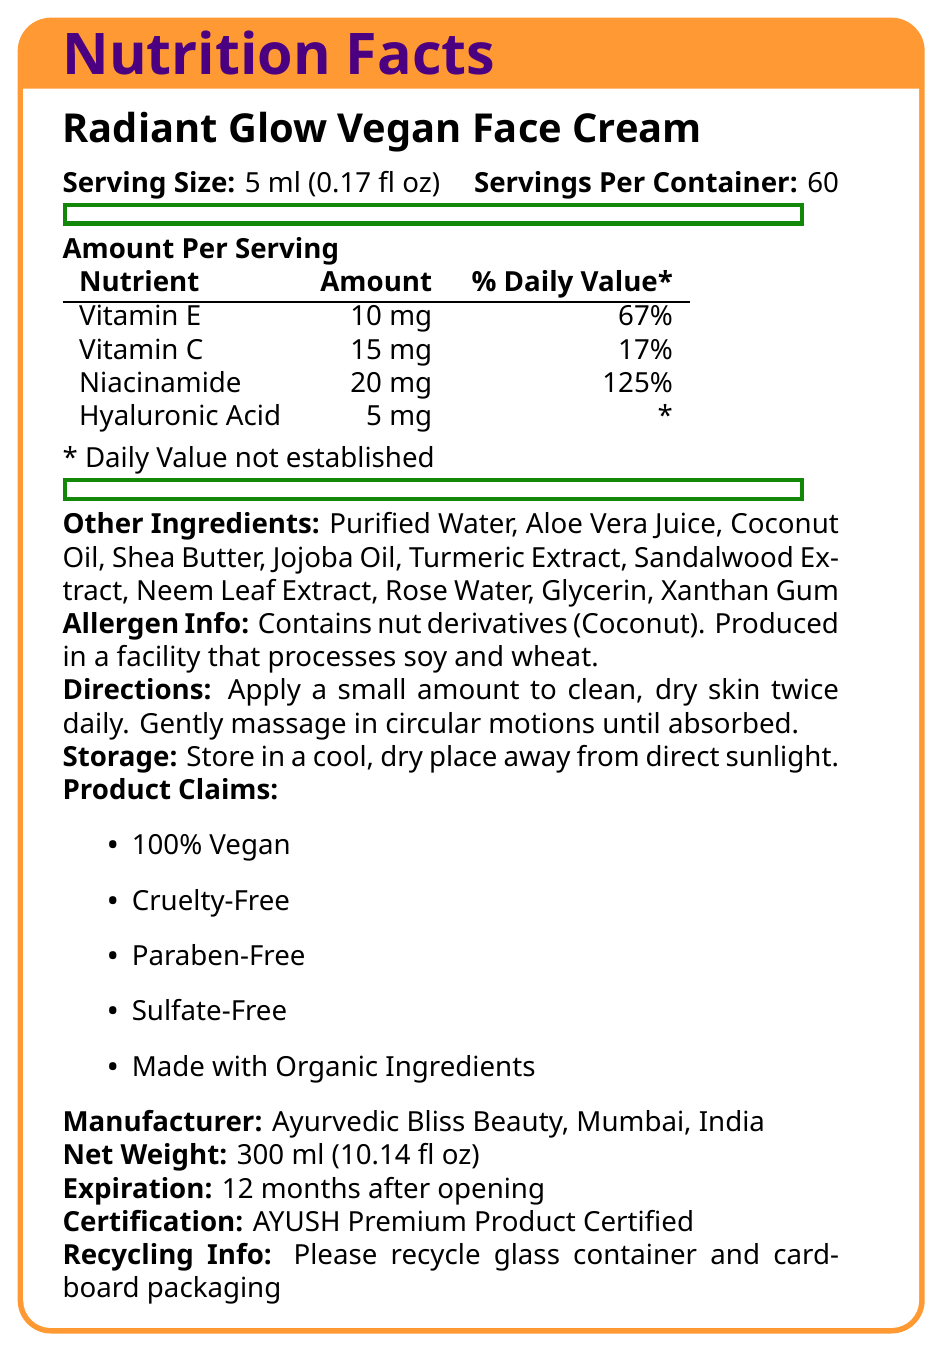what is the serving size of the product? The serving size is mentioned under the product name "Radiant Glow Vegan Face Cream".
Answer: 5 ml (0.17 fl oz) how many servings are there in the container? The number of servings per container is listed next to the serving size.
Answer: 60 which nutrient has the highest percentage daily value? Niacinamide has a daily value of 125%, which is higher than the daily values of the other listed nutrients.
Answer: Niacinamide name two key nutrients in the product and their respective daily values. The information is provided in the table under the "Amount Per Serving" section.
Answer: Vitamin E (67%) and Vitamin C (17%) what are the main ingredients in this vegan face cream? The ingredients are listed under the "Other Ingredients:" section.
Answer: Purified Water, Aloe Vera Juice, Coconut Oil, Shea Butter, Jojoba Oil, Turmeric Extract, Sandalwood Extract, Neem Leaf Extract, Rose Water, Glycerin, Xanthan Gum does the product contain any allergens? The allergen information states that the product contains nut derivatives (Coconut) and is produced in a facility that processes soy and wheat.
Answer: Yes what is the net weight of the product? The net weight is listed near the bottom of the document.
Answer: 300 ml (10.14 fl oz) where is the product manufactured? The manufacturer location is mentioned towards the end of the document.
Answer: Ayurvedic Bliss Beauty, Mumbai, India how should the product be stored? Storage instructions are listed under the "Storage:" section.
Answer: Store in a cool, dry place away from direct sunlight what is the certification the product holds? The certification is mentioned near the bottom of the document.
Answer: AYUSH Premium Product Certified how often should you use the product according to the directions? The directions state to apply the product twice daily.
Answer: Twice daily which of the following is not an ingredient in the product? A. Aloe Vera Juice B. Hyaluronic Acid C. Olive Oil D. Rose Water Olive Oil is not listed under "Other Ingredients".
Answer: C. Olive Oil what is the main claim of the product? A. Paraben-Free B. Gluten-Free C. Dermatologist-Tested D. Made with Natural Ingredients Among the listed claims, "Paraben-Free" is one of the main claims mentioned.
Answer: A. Paraben-Free is the product made with organic ingredients? One of the product claims is that it is made with organic ingredients.
Answer: Yes summarize the contents and claims of the Radiant Glow Vegan Face Cream. This summary covers the product name, serving size, key ingredients, nutritional content, claims, allergen information, certification, usage directions, and storage instructions.
Answer: The Radiant Glow Vegan Face Cream is a skincare product with a serving size of 5 ml, providing 60 servings per container. Key nutrients include Vitamin E, Vitamin C, Niacinamide, and Hyaluronic Acid. It contains natural ingredients like Aloe Vera Juice, Coconut Oil, and Neem Leaf Extract. The product is 100% vegan, cruelty-free, paraben-free, sulfate-free, and made with organic ingredients. It contains nut derivatives and is processed in a facility handling soy and wheat. The product is certified by AYUSH and should be used twice daily and stored in a cool, dry place. what is the exact date of manufacture? The document does not provide the exact date of manufacture, only the expiration date (12 months after opening).
Answer: Not enough information 